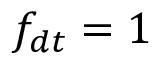<formula> <loc_0><loc_0><loc_500><loc_500>f _ { d t } = 1</formula> 